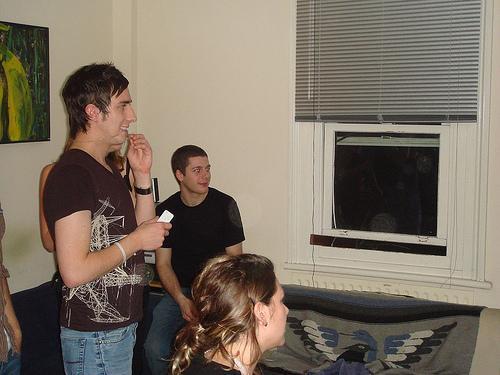How many people can you spot?
Give a very brief answer. 5. How many wii remotes are seen?
Give a very brief answer. 1. How many windows shown in the room?
Give a very brief answer. 1. 